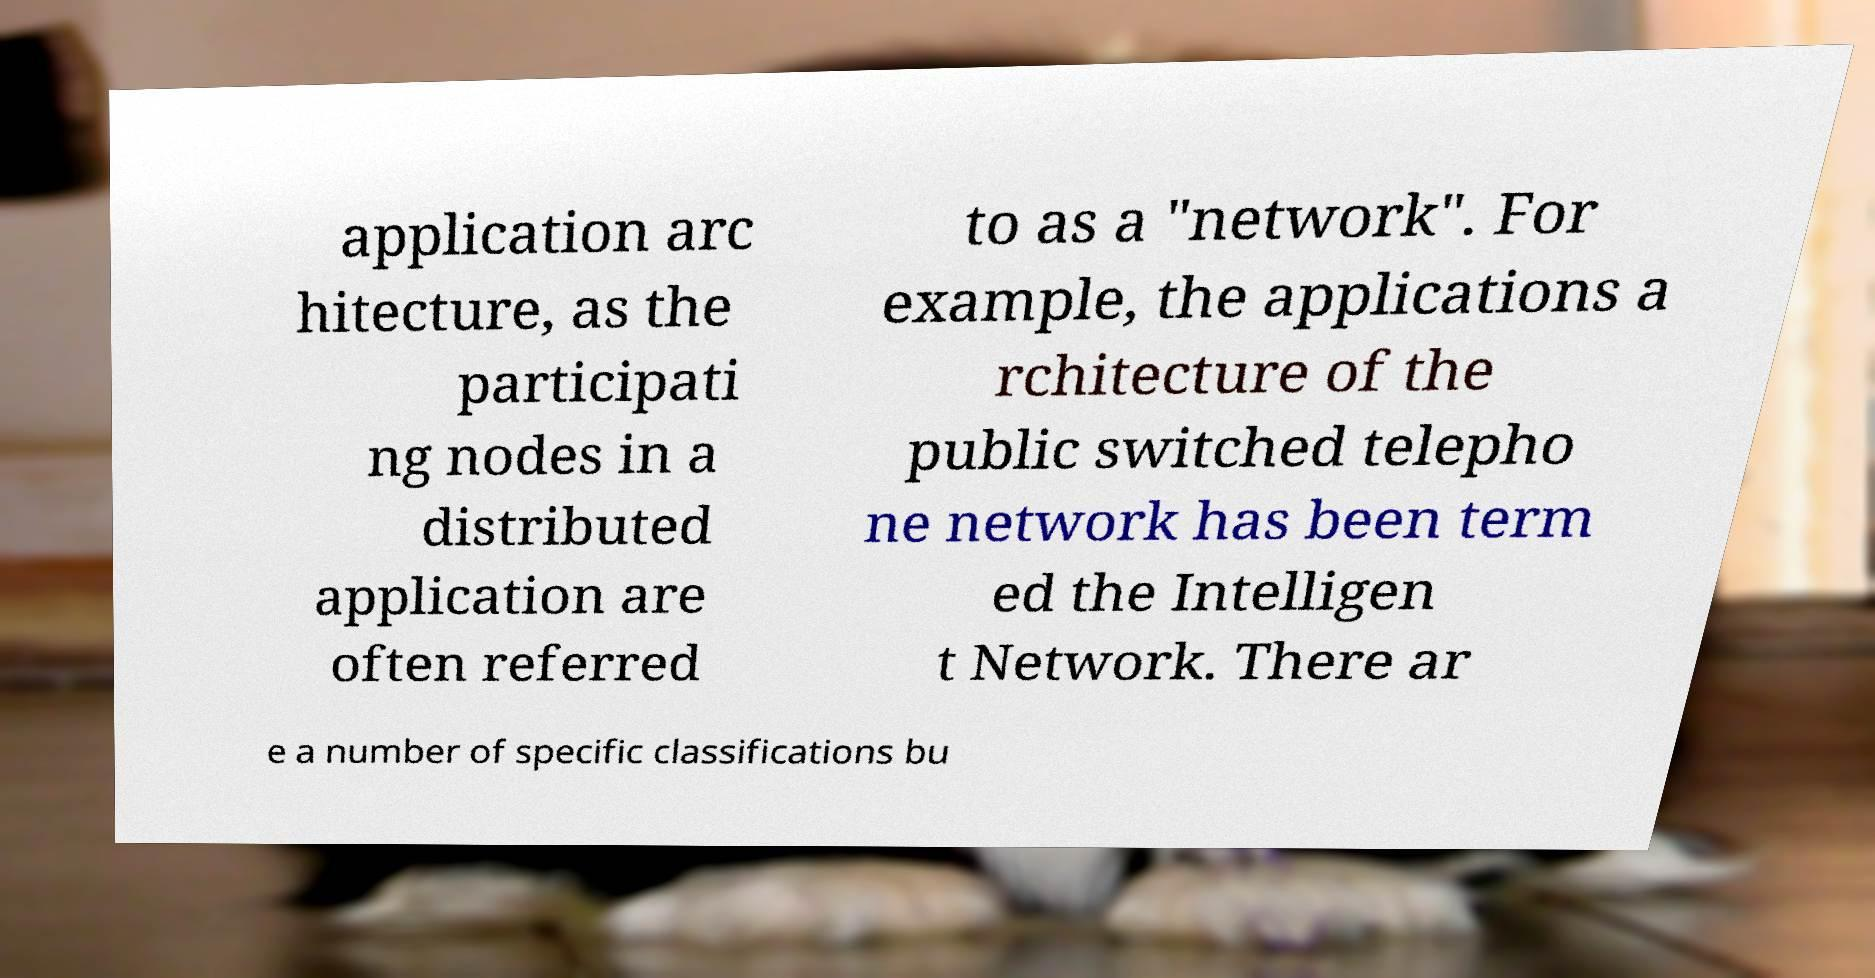Could you extract and type out the text from this image? application arc hitecture, as the participati ng nodes in a distributed application are often referred to as a "network". For example, the applications a rchitecture of the public switched telepho ne network has been term ed the Intelligen t Network. There ar e a number of specific classifications bu 